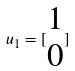Convert formula to latex. <formula><loc_0><loc_0><loc_500><loc_500>u _ { 1 } = [ \begin{matrix} 1 \\ 0 \end{matrix} ]</formula> 